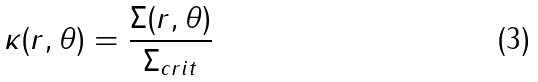<formula> <loc_0><loc_0><loc_500><loc_500>\kappa ( r , \theta ) = \frac { \Sigma ( r , \theta ) } { \Sigma _ { c r i t } }</formula> 